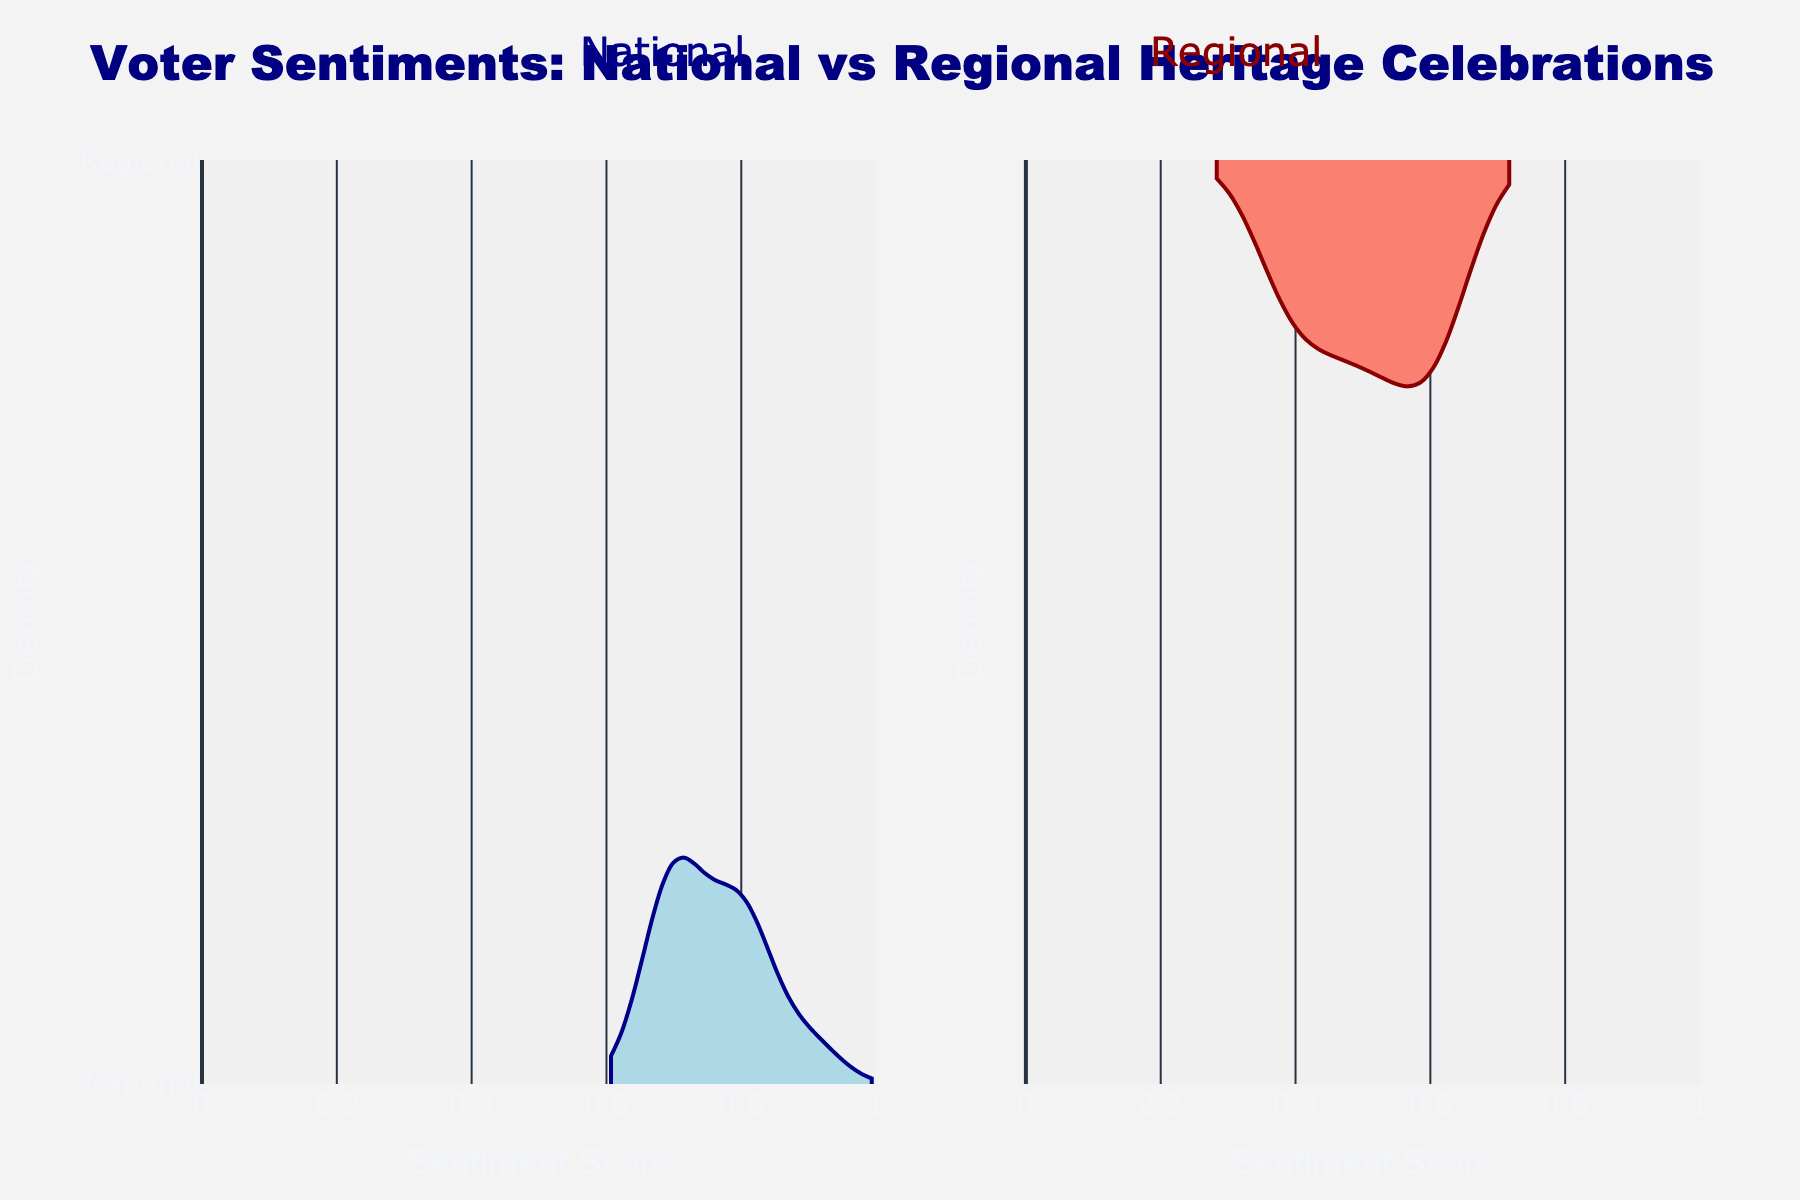What's the title of the figure? The title is clearly displayed at the top of the figure. It reads "Voter Sentiments: National vs. Regional Heritage Celebrations" which indicates the overall theme of the visualization.
Answer: Voter Sentiments: National vs Regional Heritage Celebrations What does the x-axis represent? The x-axis is labeled "Sentiment Score," indicating that it shows the range of sentiment scores voters have towards National and Regional Heritage Celebrations, from 0 to 1.
Answer: Sentiment Score What are the two sentiment types compared in this figure? The figure includes annotations and labels showing that the sentiment types are "National" (on the left) and "Regional" (on the right), comparing voter sentiments towards these two categories.
Answer: National and Regional What color represents National sentiments? The figure uses distinct colors to represent each sentiment type. National sentiments are represented by light blue with dark blue outlines.
Answer: Light blue Which sentiment type appears to have higher density scores clustered around higher values? By observing the density and spread of the violin plots, National sentiments have higher density scores around 0.7 to 0.8 compared to Regional sentiments.
Answer: National What range of sentiment scores is most common for Regional sentiments? The violin plot for Regional sentiments shows thicker density around certain scores. The most common range is around 0.4 to 0.6.
Answer: 0.4 to 0.6 Which sentiment type has more varied scores? By comparing the width and spread of both violin plots, National sentiments display a broader range and variation in scores from around 0.7 to 0.9, whereas Regional is more clustered and centered.
Answer: National How does the density distribution for National sentiments compare to Regional sentiments? National sentiments have a tighter, higher density cluster in the upper range (0.7 to 0.9), while Regional sentiments are more spread out and concentrated around mid to lower range scores (0.4 to 0.6).
Answer: National is tight at high, Regional is spread at mid-low 